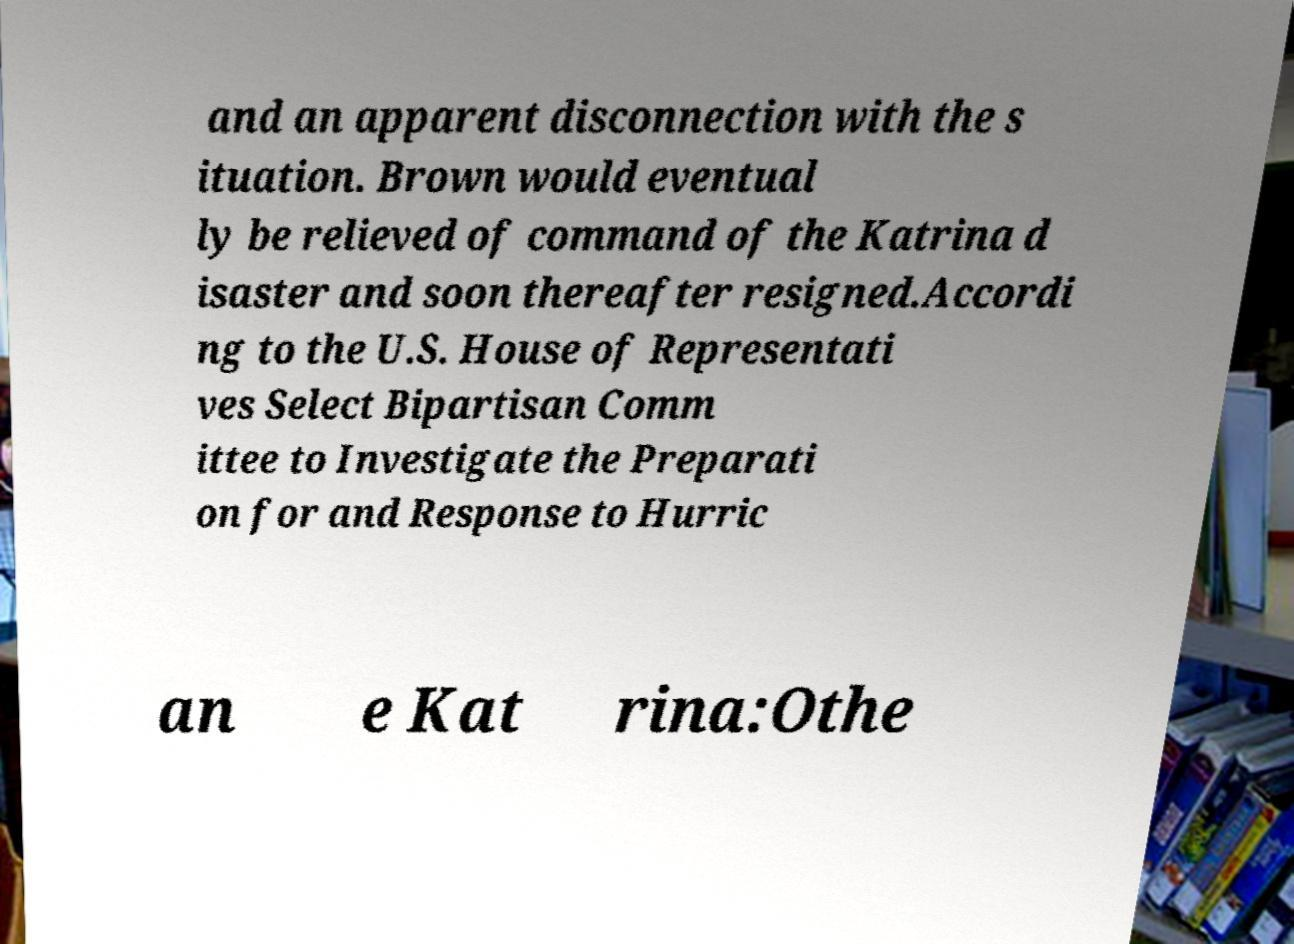Please read and relay the text visible in this image. What does it say? and an apparent disconnection with the s ituation. Brown would eventual ly be relieved of command of the Katrina d isaster and soon thereafter resigned.Accordi ng to the U.S. House of Representati ves Select Bipartisan Comm ittee to Investigate the Preparati on for and Response to Hurric an e Kat rina:Othe 